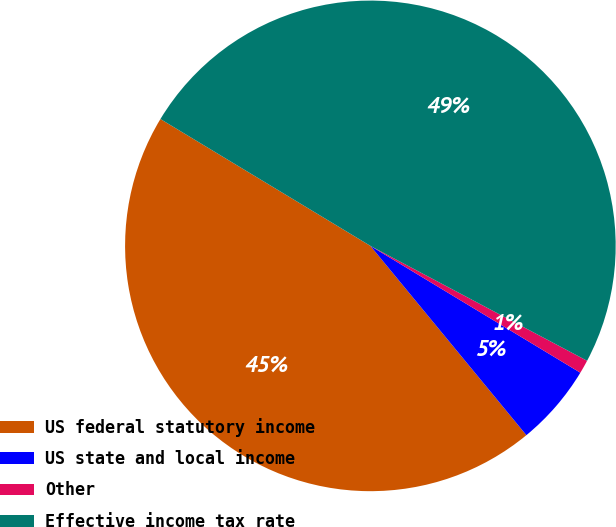Convert chart to OTSL. <chart><loc_0><loc_0><loc_500><loc_500><pie_chart><fcel>US federal statutory income<fcel>US state and local income<fcel>Other<fcel>Effective income tax rate<nl><fcel>44.62%<fcel>5.38%<fcel>0.89%<fcel>49.11%<nl></chart> 